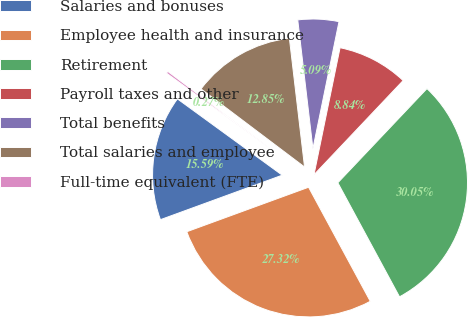Convert chart to OTSL. <chart><loc_0><loc_0><loc_500><loc_500><pie_chart><fcel>Salaries and bonuses<fcel>Employee health and insurance<fcel>Retirement<fcel>Payroll taxes and other<fcel>Total benefits<fcel>Total salaries and employee<fcel>Full-time equivalent (FTE)<nl><fcel>15.59%<fcel>27.32%<fcel>30.05%<fcel>8.84%<fcel>5.09%<fcel>12.85%<fcel>0.27%<nl></chart> 